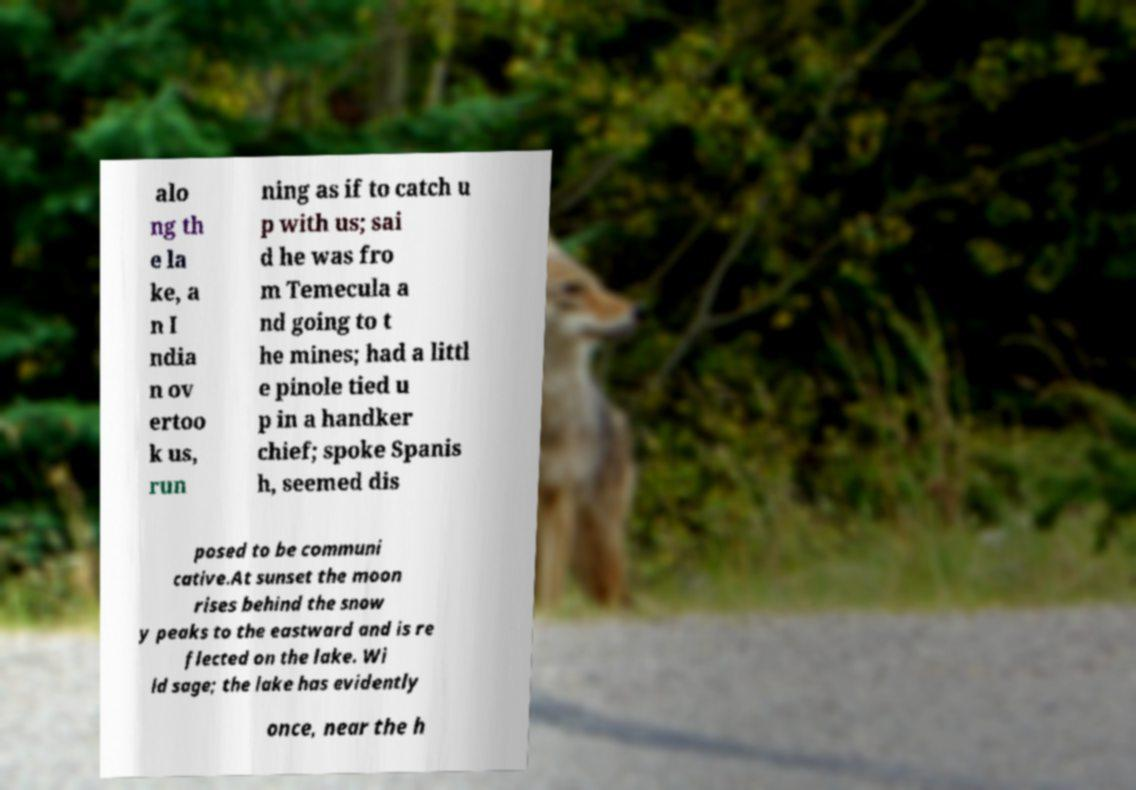Please identify and transcribe the text found in this image. alo ng th e la ke, a n I ndia n ov ertoo k us, run ning as if to catch u p with us; sai d he was fro m Temecula a nd going to t he mines; had a littl e pinole tied u p in a handker chief; spoke Spanis h, seemed dis posed to be communi cative.At sunset the moon rises behind the snow y peaks to the eastward and is re flected on the lake. Wi ld sage; the lake has evidently once, near the h 